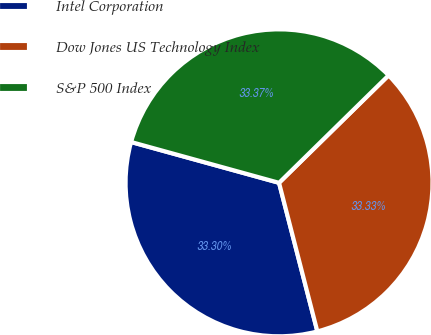Convert chart to OTSL. <chart><loc_0><loc_0><loc_500><loc_500><pie_chart><fcel>Intel Corporation<fcel>Dow Jones US Technology Index<fcel>S&P 500 Index<nl><fcel>33.3%<fcel>33.33%<fcel>33.37%<nl></chart> 